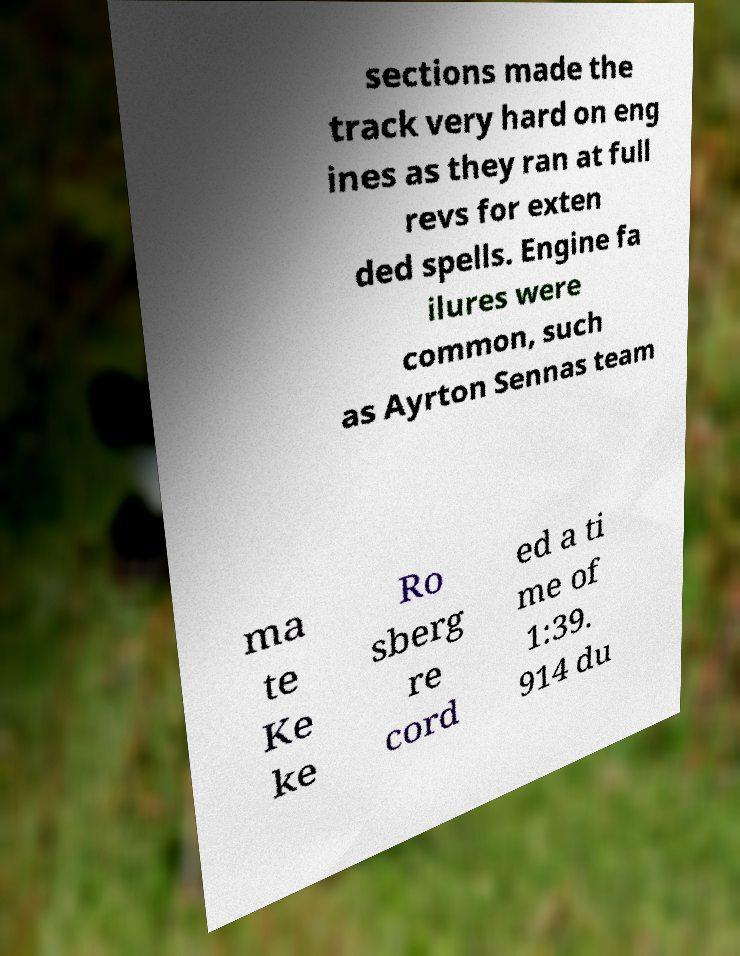I need the written content from this picture converted into text. Can you do that? sections made the track very hard on eng ines as they ran at full revs for exten ded spells. Engine fa ilures were common, such as Ayrton Sennas team ma te Ke ke Ro sberg re cord ed a ti me of 1:39. 914 du 